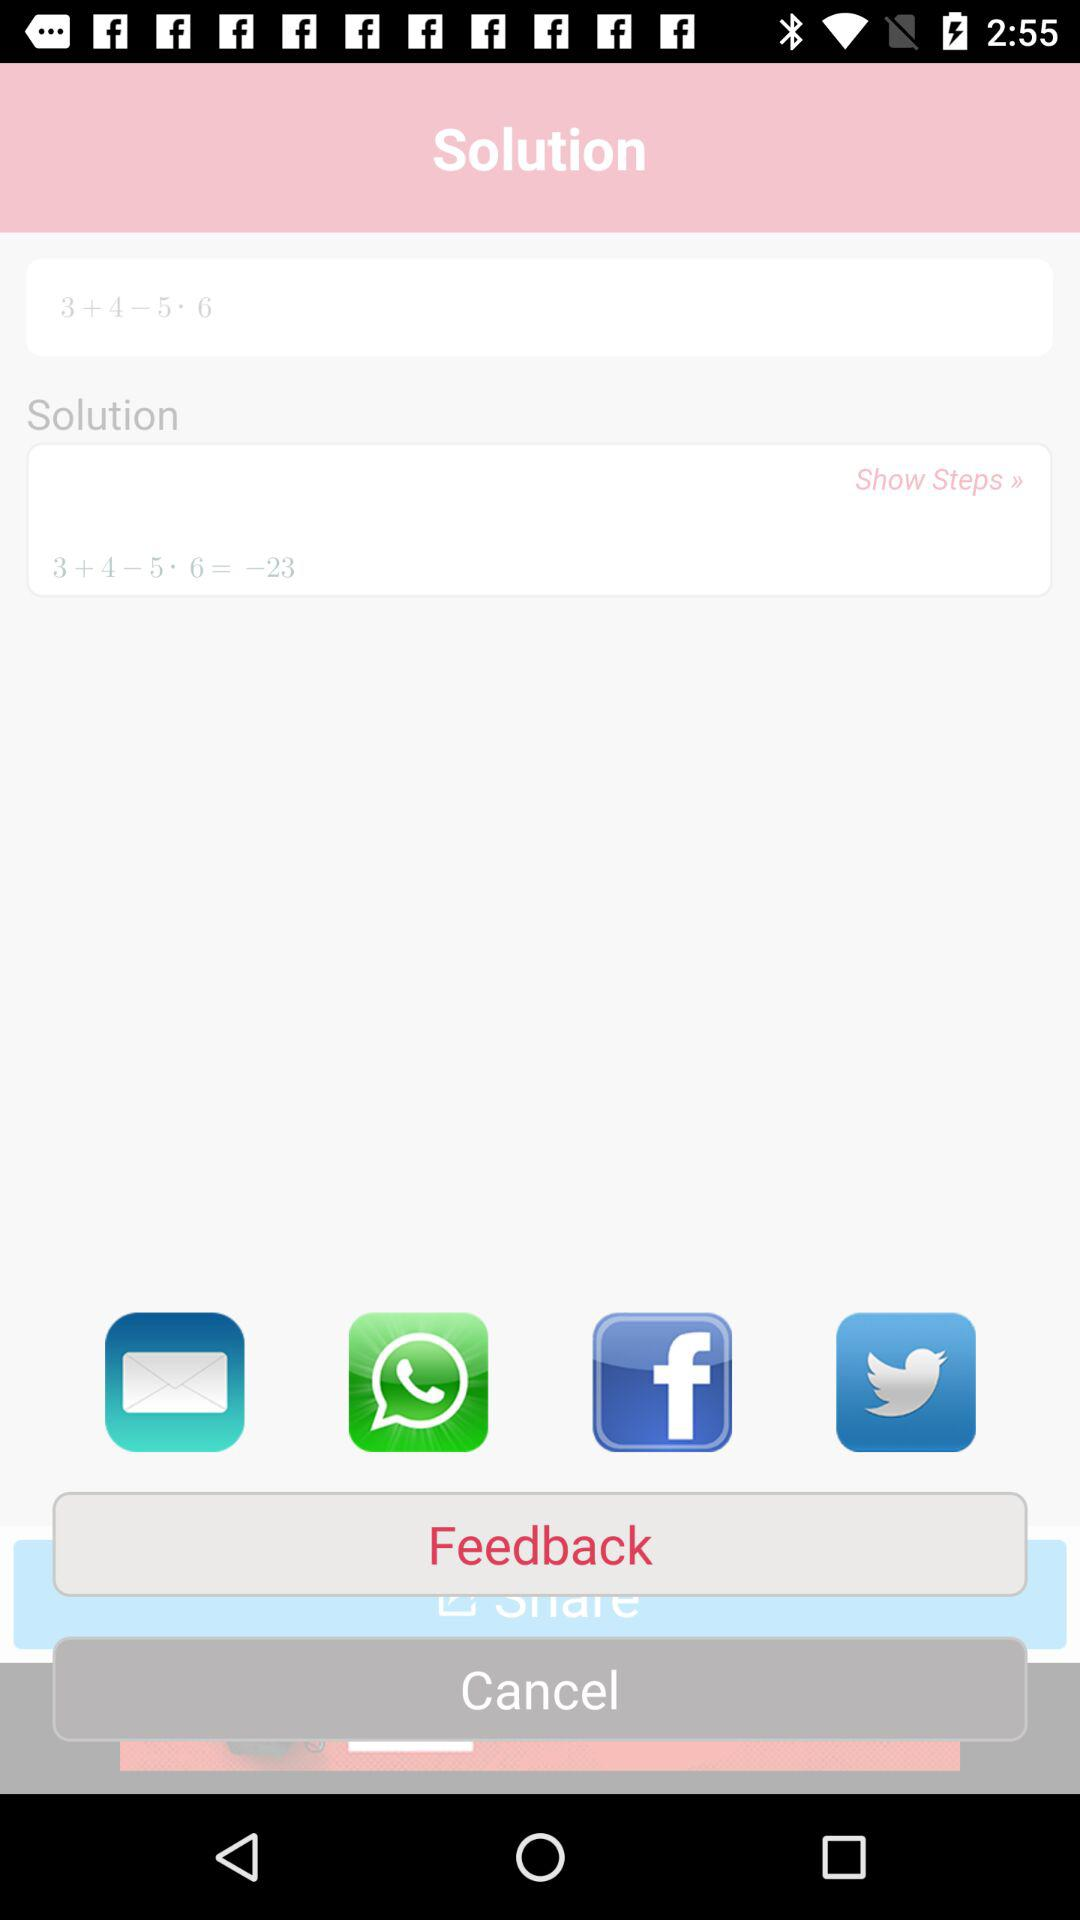What is the result of the calculation?
Answer the question using a single word or phrase. -23 